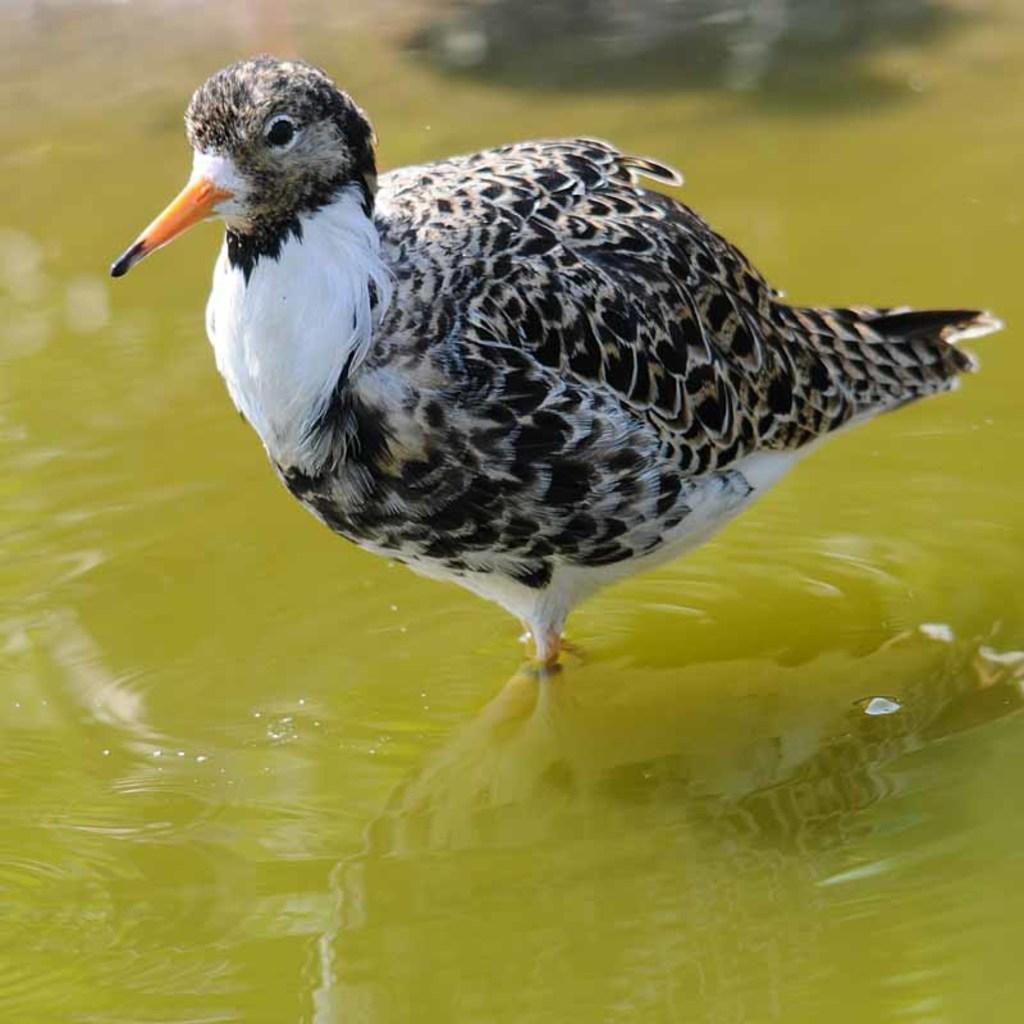Where was the image taken? The image was taken outdoors. What can be seen at the bottom of the image? There is a pond with water at the bottom of the image. What is located in the middle of the image? There is a bird in the middle of the image. What type of screw can be seen on the ground in the image? There is no screw present on the ground in the image. 